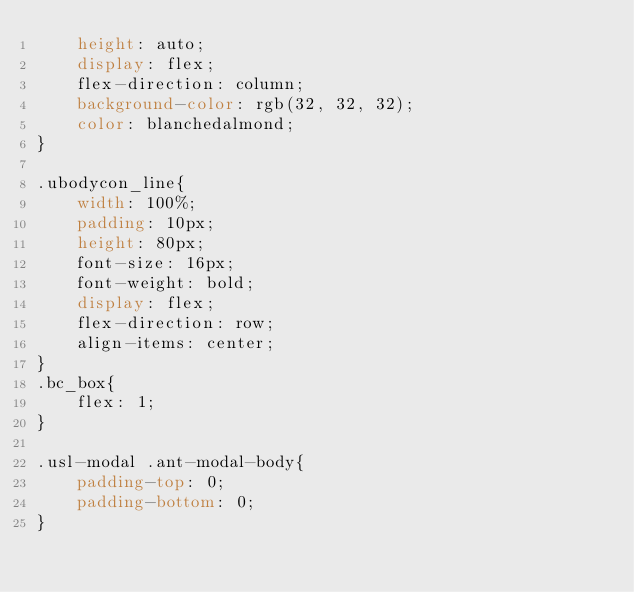<code> <loc_0><loc_0><loc_500><loc_500><_CSS_>    height: auto;
    display: flex;
    flex-direction: column;
    background-color: rgb(32, 32, 32);
    color: blanchedalmond;
}

.ubodycon_line{
    width: 100%;
    padding: 10px;
    height: 80px;
    font-size: 16px;
    font-weight: bold;
    display: flex;
    flex-direction: row;
    align-items: center;
}
.bc_box{
    flex: 1;
}

.usl-modal .ant-modal-body{
    padding-top: 0;
    padding-bottom: 0;
}
</code> 